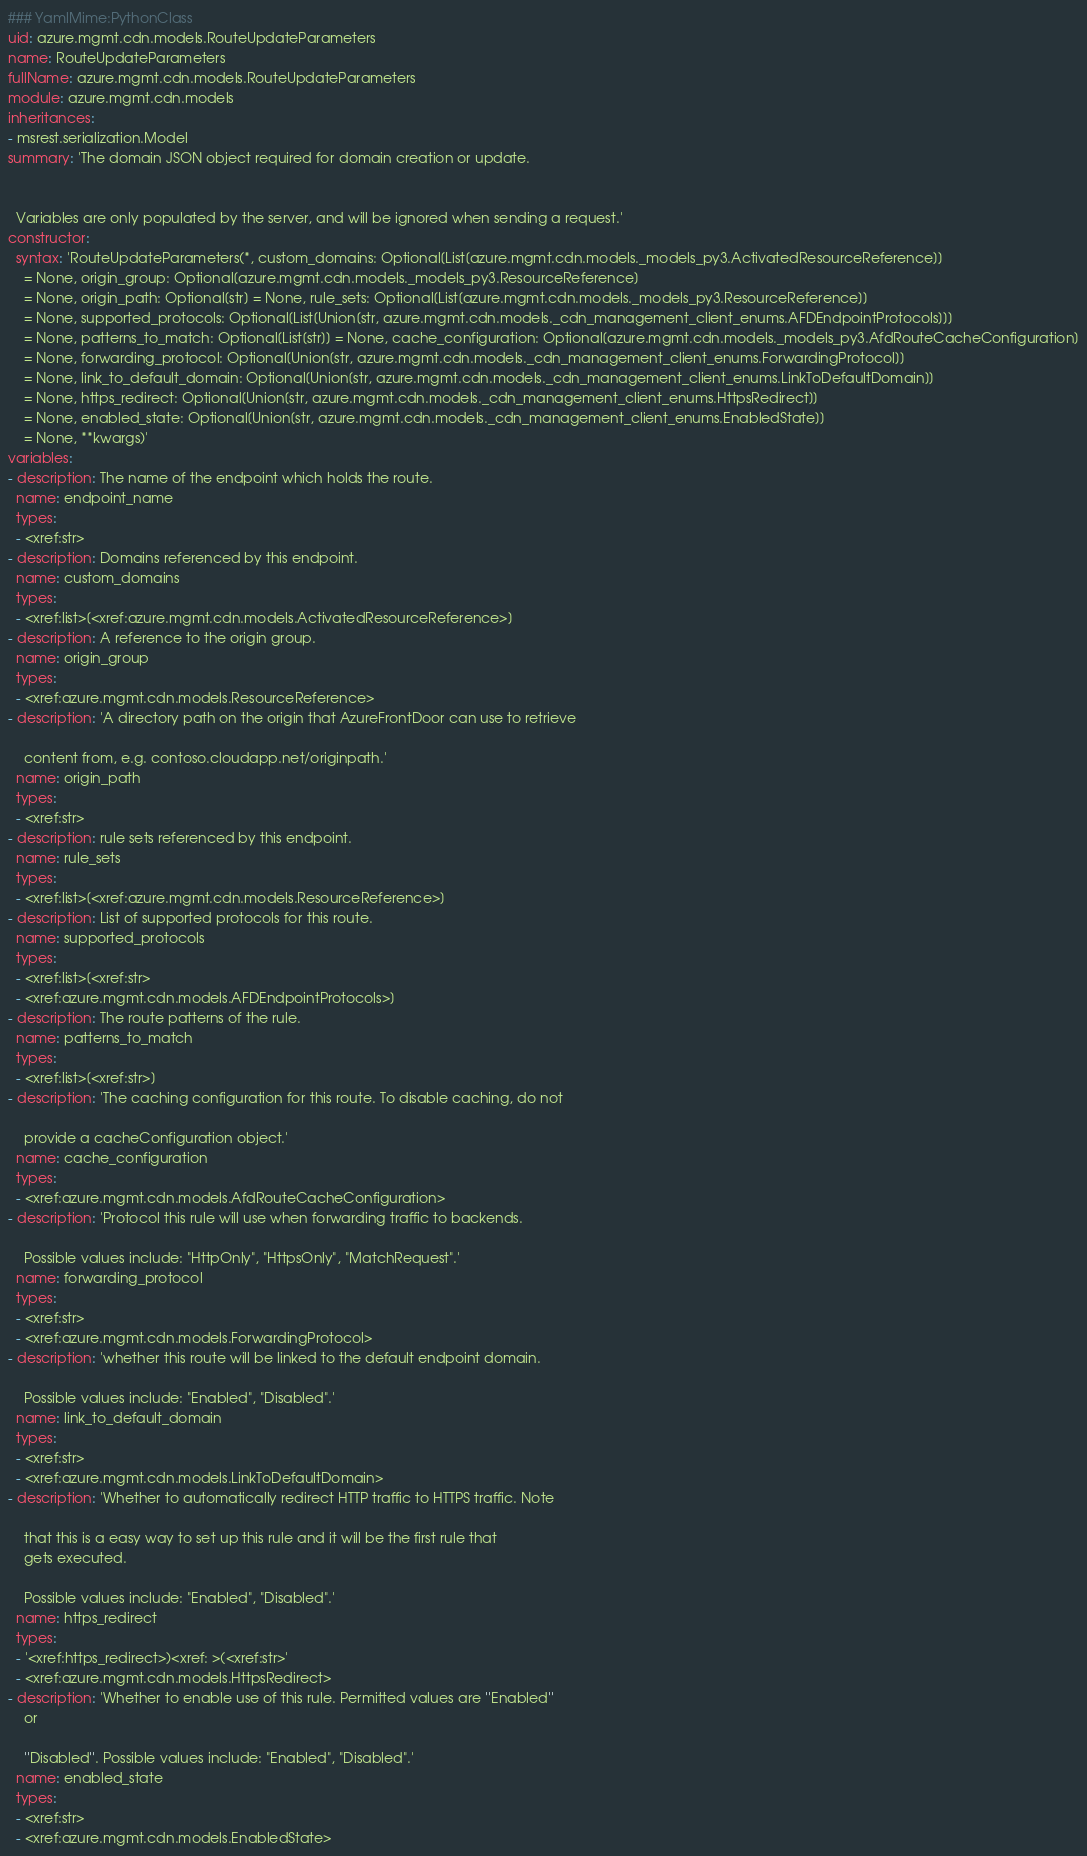Convert code to text. <code><loc_0><loc_0><loc_500><loc_500><_YAML_>### YamlMime:PythonClass
uid: azure.mgmt.cdn.models.RouteUpdateParameters
name: RouteUpdateParameters
fullName: azure.mgmt.cdn.models.RouteUpdateParameters
module: azure.mgmt.cdn.models
inheritances:
- msrest.serialization.Model
summary: 'The domain JSON object required for domain creation or update.


  Variables are only populated by the server, and will be ignored when sending a request.'
constructor:
  syntax: 'RouteUpdateParameters(*, custom_domains: Optional[List[azure.mgmt.cdn.models._models_py3.ActivatedResourceReference]]
    = None, origin_group: Optional[azure.mgmt.cdn.models._models_py3.ResourceReference]
    = None, origin_path: Optional[str] = None, rule_sets: Optional[List[azure.mgmt.cdn.models._models_py3.ResourceReference]]
    = None, supported_protocols: Optional[List[Union[str, azure.mgmt.cdn.models._cdn_management_client_enums.AFDEndpointProtocols]]]
    = None, patterns_to_match: Optional[List[str]] = None, cache_configuration: Optional[azure.mgmt.cdn.models._models_py3.AfdRouteCacheConfiguration]
    = None, forwarding_protocol: Optional[Union[str, azure.mgmt.cdn.models._cdn_management_client_enums.ForwardingProtocol]]
    = None, link_to_default_domain: Optional[Union[str, azure.mgmt.cdn.models._cdn_management_client_enums.LinkToDefaultDomain]]
    = None, https_redirect: Optional[Union[str, azure.mgmt.cdn.models._cdn_management_client_enums.HttpsRedirect]]
    = None, enabled_state: Optional[Union[str, azure.mgmt.cdn.models._cdn_management_client_enums.EnabledState]]
    = None, **kwargs)'
variables:
- description: The name of the endpoint which holds the route.
  name: endpoint_name
  types:
  - <xref:str>
- description: Domains referenced by this endpoint.
  name: custom_domains
  types:
  - <xref:list>[<xref:azure.mgmt.cdn.models.ActivatedResourceReference>]
- description: A reference to the origin group.
  name: origin_group
  types:
  - <xref:azure.mgmt.cdn.models.ResourceReference>
- description: 'A directory path on the origin that AzureFrontDoor can use to retrieve

    content from, e.g. contoso.cloudapp.net/originpath.'
  name: origin_path
  types:
  - <xref:str>
- description: rule sets referenced by this endpoint.
  name: rule_sets
  types:
  - <xref:list>[<xref:azure.mgmt.cdn.models.ResourceReference>]
- description: List of supported protocols for this route.
  name: supported_protocols
  types:
  - <xref:list>[<xref:str>
  - <xref:azure.mgmt.cdn.models.AFDEndpointProtocols>]
- description: The route patterns of the rule.
  name: patterns_to_match
  types:
  - <xref:list>[<xref:str>]
- description: 'The caching configuration for this route. To disable caching, do not

    provide a cacheConfiguration object.'
  name: cache_configuration
  types:
  - <xref:azure.mgmt.cdn.models.AfdRouteCacheConfiguration>
- description: 'Protocol this rule will use when forwarding traffic to backends.

    Possible values include: "HttpOnly", "HttpsOnly", "MatchRequest".'
  name: forwarding_protocol
  types:
  - <xref:str>
  - <xref:azure.mgmt.cdn.models.ForwardingProtocol>
- description: 'whether this route will be linked to the default endpoint domain.

    Possible values include: "Enabled", "Disabled".'
  name: link_to_default_domain
  types:
  - <xref:str>
  - <xref:azure.mgmt.cdn.models.LinkToDefaultDomain>
- description: 'Whether to automatically redirect HTTP traffic to HTTPS traffic. Note

    that this is a easy way to set up this rule and it will be the first rule that
    gets executed.

    Possible values include: "Enabled", "Disabled".'
  name: https_redirect
  types:
  - '<xref:https_redirect>)<xref: >(<xref:str>'
  - <xref:azure.mgmt.cdn.models.HttpsRedirect>
- description: 'Whether to enable use of this rule. Permitted values are ''Enabled''
    or

    ''Disabled''. Possible values include: "Enabled", "Disabled".'
  name: enabled_state
  types:
  - <xref:str>
  - <xref:azure.mgmt.cdn.models.EnabledState>
</code> 